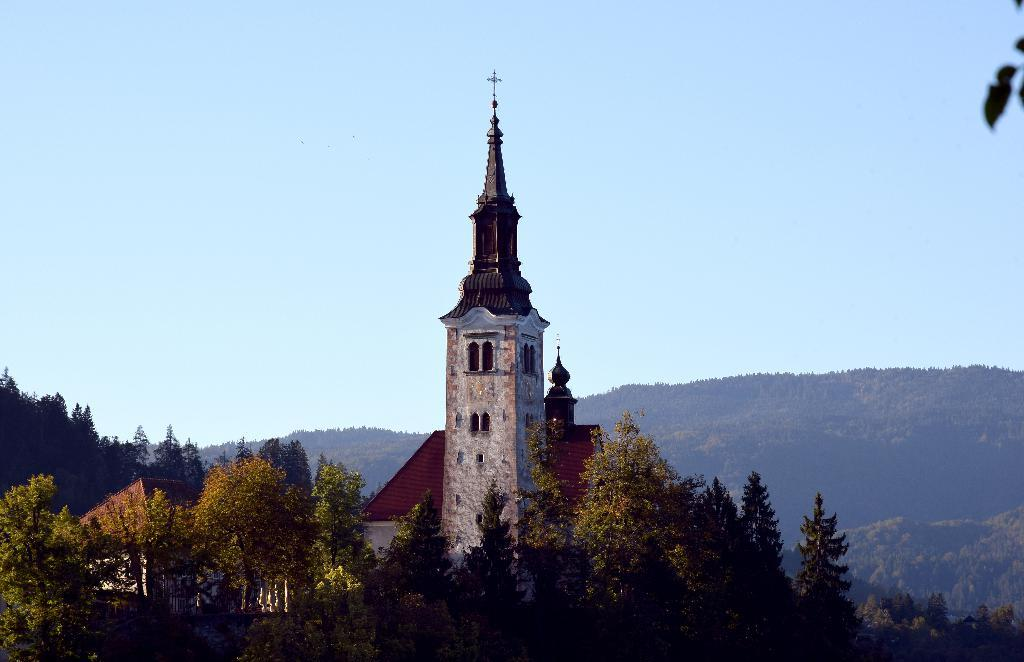What type of natural elements can be seen in the image? There are trees in the image. What type of man-made structures are present in the image? There are buildings in the image. What can be seen in the background of the image? The sky is visible in the background of the image. How many deer can be seen in the image? There are no deer present in the image. Is there a tiger visible in the image? There is no tiger present in the image. 